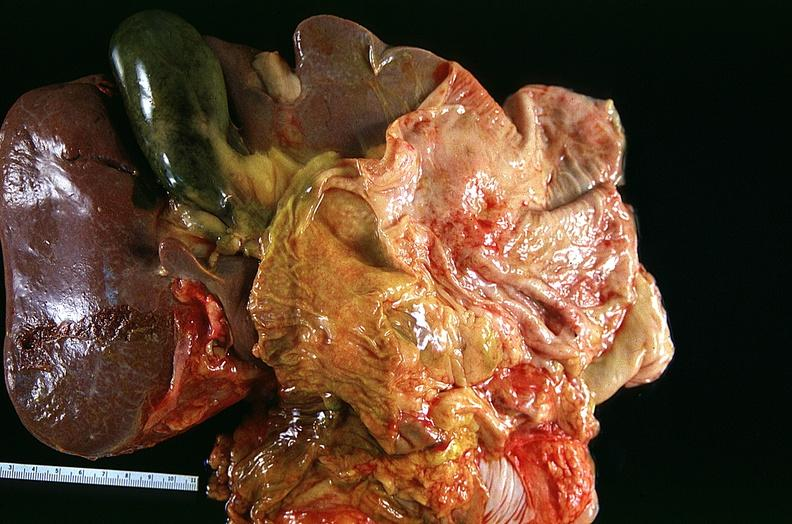does this image show lung, squamous cell carcinoma?
Answer the question using a single word or phrase. Yes 